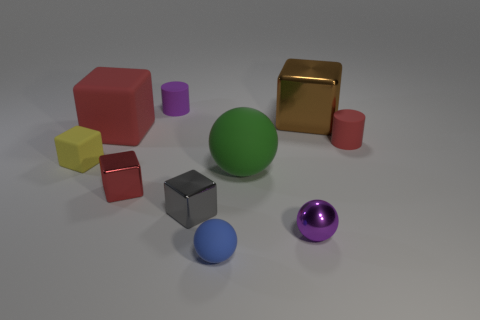How many things are brown shiny cubes or tiny cyan blocks?
Keep it short and to the point. 1. There is a large brown object that is made of the same material as the purple sphere; what is its shape?
Provide a short and direct response. Cube. How many big objects are either purple matte cylinders or red metallic blocks?
Provide a succinct answer. 0. What number of other things are the same color as the metallic ball?
Your answer should be very brief. 1. There is a metallic block that is on the right side of the ball that is to the right of the green rubber sphere; what number of brown metal cubes are on the left side of it?
Make the answer very short. 0. Do the matte object that is right of the green sphere and the green thing have the same size?
Keep it short and to the point. No. Are there fewer cylinders that are in front of the purple shiny ball than blue spheres behind the large metallic thing?
Your answer should be compact. No. Is the color of the large matte block the same as the small matte cube?
Offer a terse response. No. Is the number of large green objects to the right of the large brown block less than the number of red cylinders?
Provide a succinct answer. Yes. There is a tiny cylinder that is the same color as the small shiny ball; what is it made of?
Offer a very short reply. Rubber. 